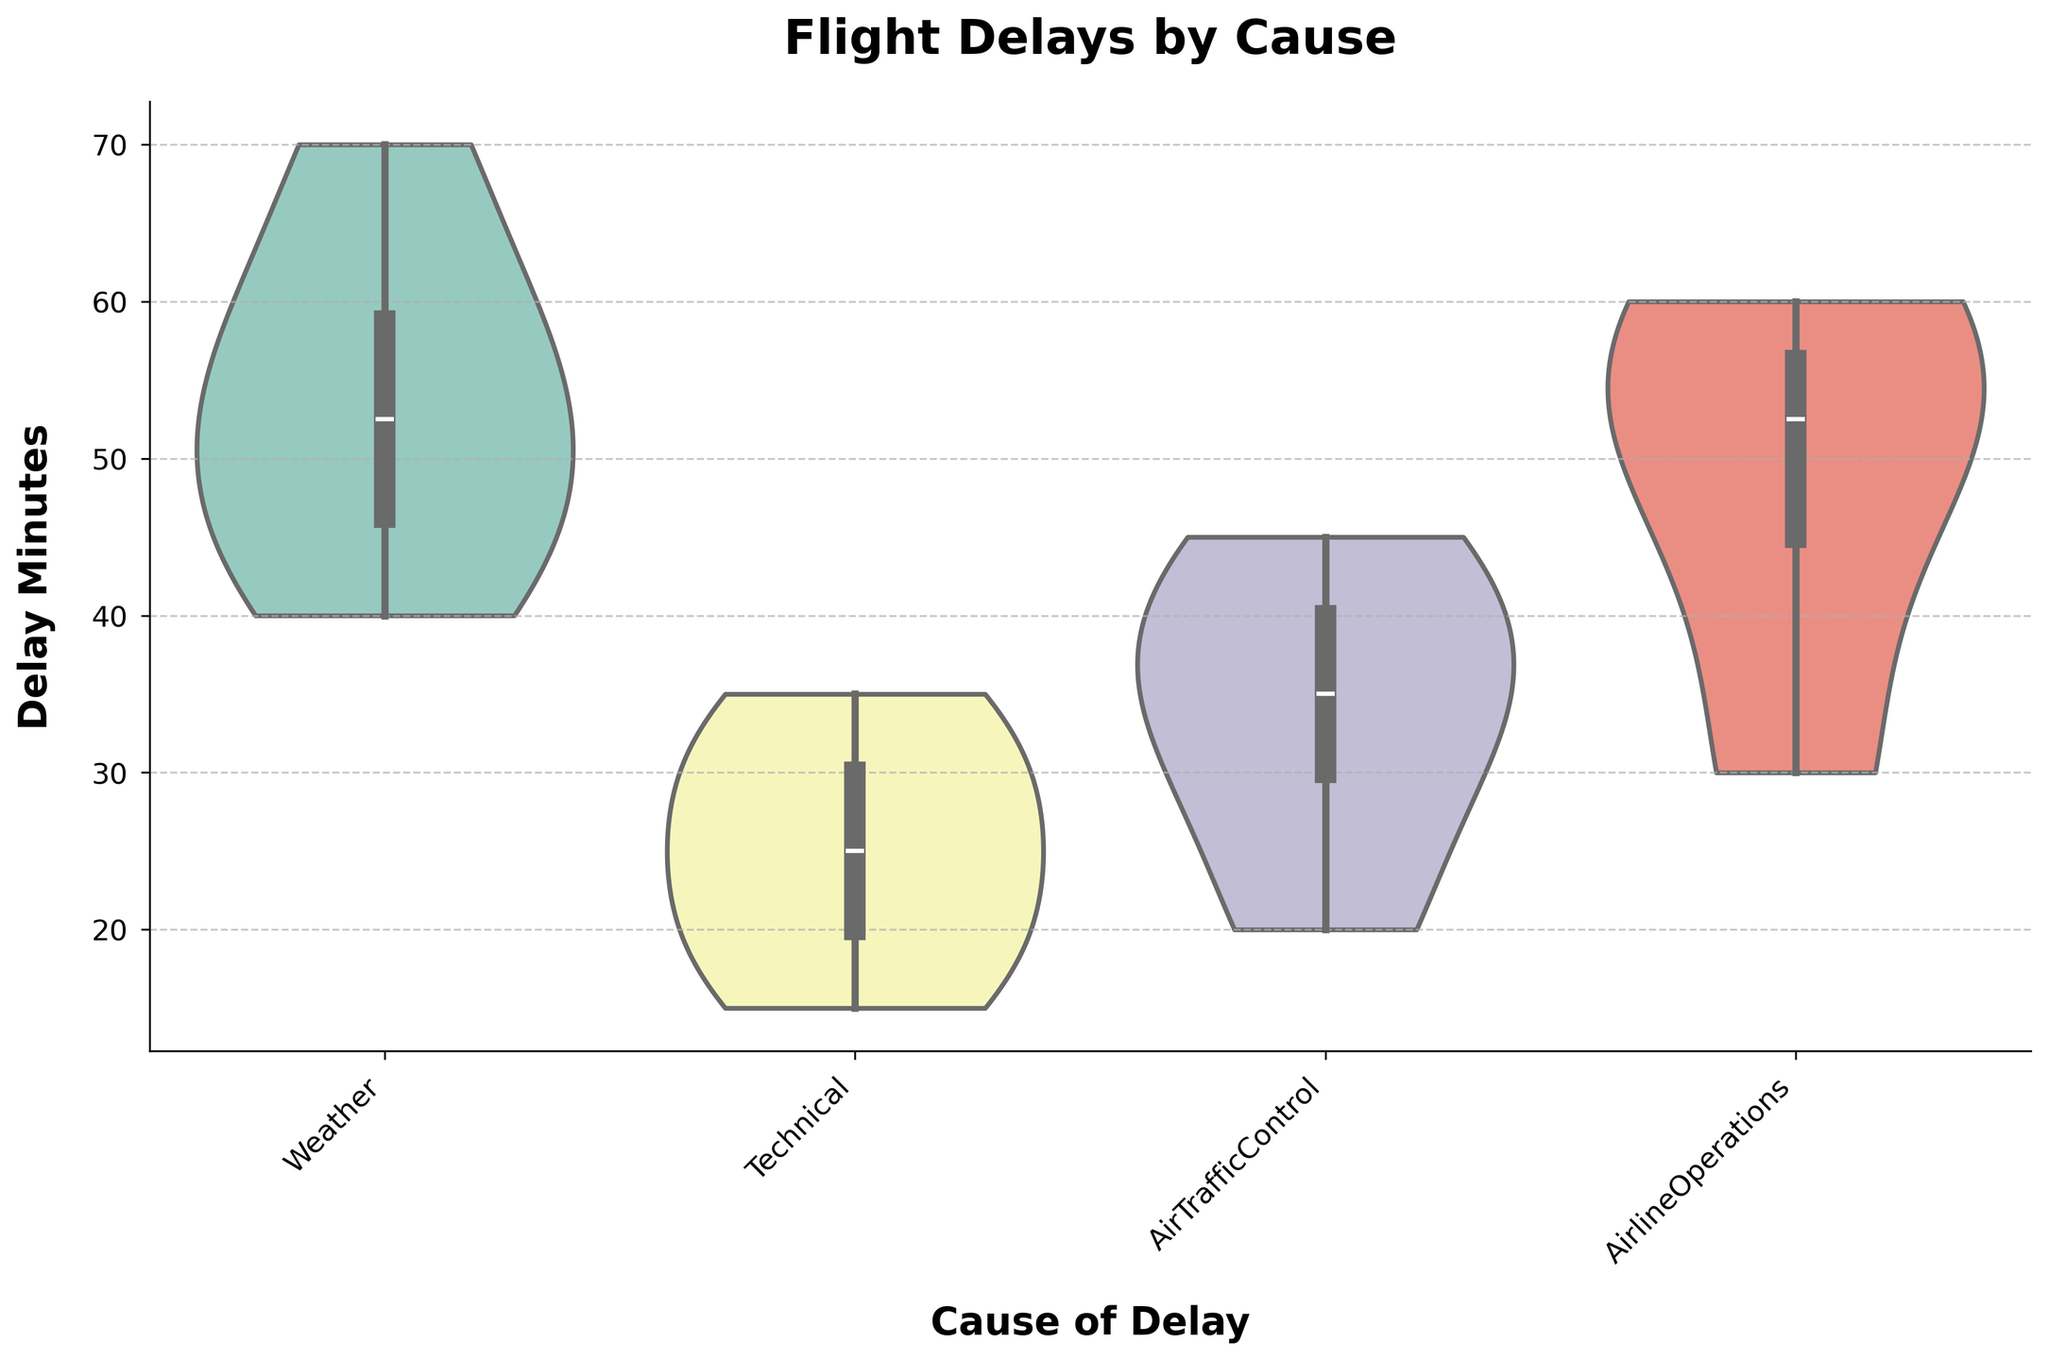What is the title of the figure? The title can be found at the top of the figure. It is usually the most prominent text in the visualization.
Answer: Flight Delays by Cause What are the causes of delays shown in the figure? The causes of delays are shown along the x-axis of the figure, representing different categories of delays.
Answer: Weather, Technical, AirTrafficControl, AirlineOperations What is the range of delay minutes displayed on the y-axis? The range of delay minutes is shown on the y-axis, which goes from the minimum to the maximum delay times. By reading the axis labels, we can determine this range.
Answer: 0 to 80 Which cause of delay has the highest median delay? The median delay for each cause can be inferred from the center of the box within the violin plots. The highest median corresponds to the plot with the center line at the highest position.
Answer: Weather Which cause of delay has the smallest range of delay minutes? The range of delay minutes for each cause can be determined by looking at the length of each violin plot. The plot with the shortest length has the smallest range.
Answer: Technical How do the distributions of delays for Technical and Air Traffic Control compare? To compare the distributions, observe the shape, spread, and median line of the violin plots for Technical and Air Traffic Control. Consider aspects such as the width and height of the plots.
Answer: Air Traffic Control has a wider and flatter distribution with a lower median compared to Technical, which is taller and narrower What is the interquartile range (IQR) of delay minutes for Airline Operations? The IQR is the range between the first (Q1) and third quartile (Q3) within the violin plot. These are typically marked by the edges of the box inside the plot. By estimating these points visually, we can calculate the IQR.
Answer: Approximately 30 to 55 (IQR is 25 minutes) Which cause of delay has the most variability in delay times? Variability can be inferred from the overall spread of the violin plot. The cause with the widest and tallest spread indicates higher variability.
Answer: Weather How does the median delay for Airline Operations compare with the median delay for Weather? Compare the center line (median) of the violin plots for both Airline Operations and Weather. The plot with the higher median line indicates a higher median delay.
Answer: The median for Weather is higher than for Airline Operations 